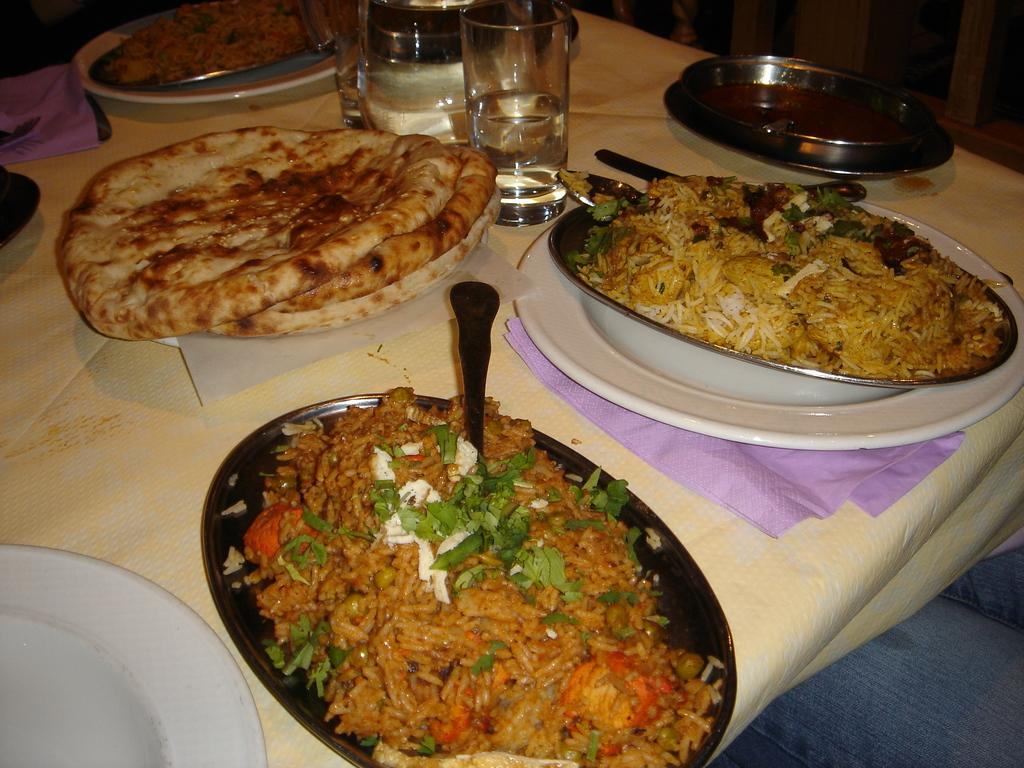What is the main piece of furniture in the image? There is a table in the image. What is on the table? The table contains food in plates, spoons, glasses, tissue papers, and napkins. What might be used for eating the food on the table? Spoons are visible on the table. What might be used for cleaning or wiping during the meal? Napkins are on the table. What type of jeans can be seen hanging from the table in the image? There are no jeans present in the image; it only features a table with food, utensils, and other items. 